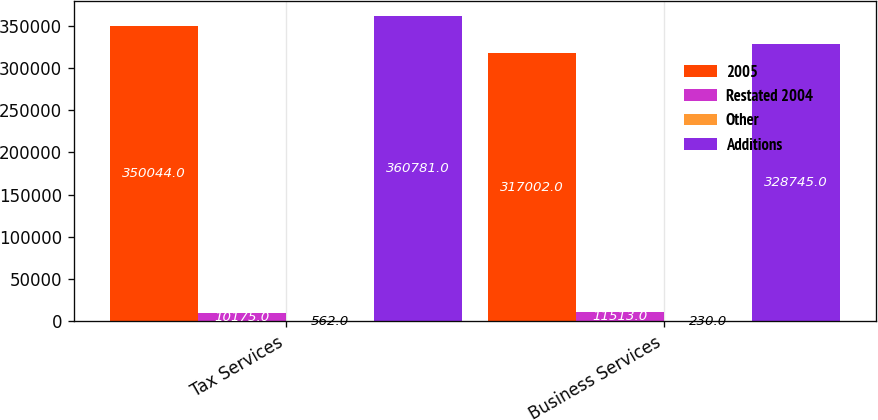Convert chart to OTSL. <chart><loc_0><loc_0><loc_500><loc_500><stacked_bar_chart><ecel><fcel>Tax Services<fcel>Business Services<nl><fcel>2005<fcel>350044<fcel>317002<nl><fcel>Restated 2004<fcel>10175<fcel>11513<nl><fcel>Other<fcel>562<fcel>230<nl><fcel>Additions<fcel>360781<fcel>328745<nl></chart> 